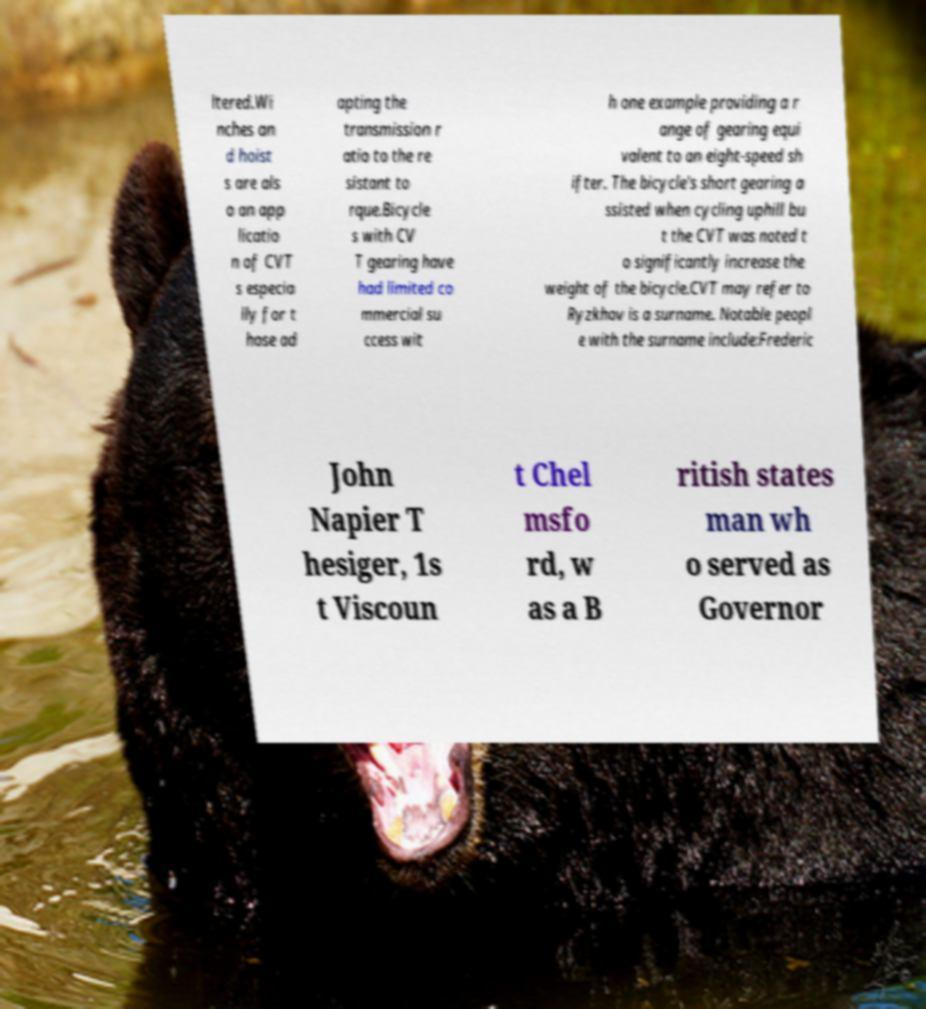For documentation purposes, I need the text within this image transcribed. Could you provide that? ltered.Wi nches an d hoist s are als o an app licatio n of CVT s especia lly for t hose ad apting the transmission r atio to the re sistant to rque.Bicycle s with CV T gearing have had limited co mmercial su ccess wit h one example providing a r ange of gearing equi valent to an eight-speed sh ifter. The bicycle's short gearing a ssisted when cycling uphill bu t the CVT was noted t o significantly increase the weight of the bicycle.CVT may refer to Ryzkhov is a surname. Notable peopl e with the surname include:Frederic John Napier T hesiger, 1s t Viscoun t Chel msfo rd, w as a B ritish states man wh o served as Governor 